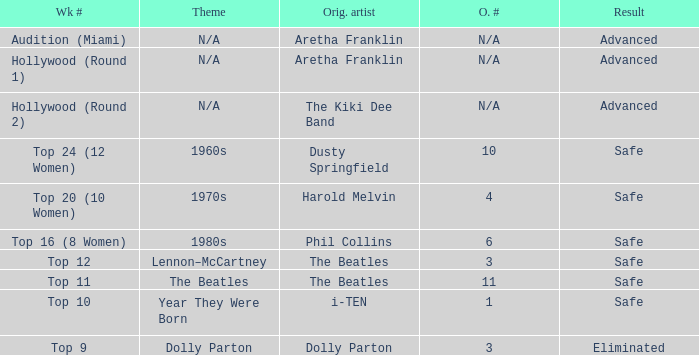What is the original artist that has 11 as the order number? The Beatles. 